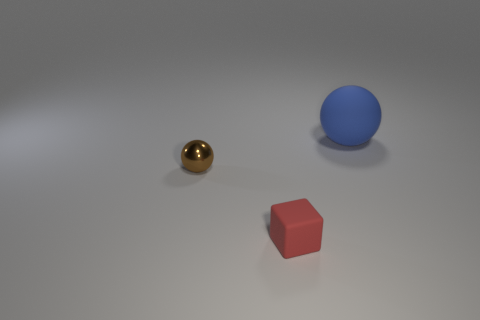Add 2 small gray balls. How many objects exist? 5 Subtract all cubes. How many objects are left? 2 Add 1 large matte balls. How many large matte balls are left? 2 Add 3 big balls. How many big balls exist? 4 Subtract 0 brown cubes. How many objects are left? 3 Subtract all small matte things. Subtract all red cubes. How many objects are left? 1 